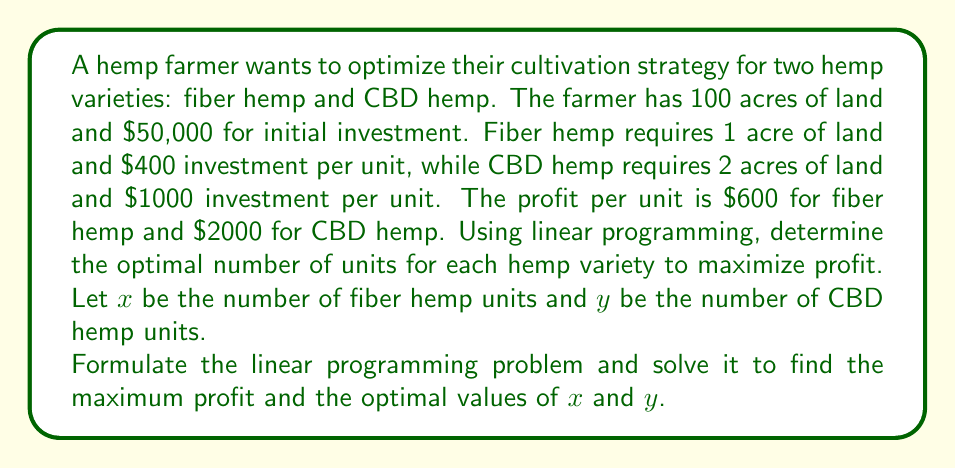Give your solution to this math problem. To solve this linear programming problem, we'll follow these steps:

1. Formulate the objective function and constraints:

   Objective function (maximize profit): 
   $$Z = 600x + 2000y$$

   Constraints:
   Land constraint: $x + 2y \leq 100$ (acres)
   Investment constraint: $400x + 1000y \leq 50000$ (dollars)
   Non-negativity: $x \geq 0, y \geq 0$

2. Graph the constraints:

   [asy]
   size(200,200);
   import graph;

   xaxis("x", 0, 120, Arrow);
   yaxis("y", 0, 60, Arrow);

   draw((0,50)--(100,0), blue);
   draw((0,50)--(125,0), red);
   draw((100,0)--(100,50), green);

   label("Land constraint", (50,25), E, blue);
   label("Investment constraint", (62.5,25), E, red);
   label("x = 100", (100,25), W, green);

   fill((0,0)--(0,50)--(50,25)--(100,0)--cycle, gray(0.8));
   [/asy]

3. Identify the feasible region (shaded area in the graph).

4. Find the corner points of the feasible region:
   (0,0), (0,50), (50,25), (100,0)

5. Evaluate the objective function at each corner point:
   (0,0): Z = 0
   (0,50): Z = 100,000
   (50,25): Z = 80,000
   (100,0): Z = 60,000

6. The maximum value occurs at (0,50), which means:
   x = 0 (fiber hemp units)
   y = 50 (CBD hemp units)

7. Calculate the maximum profit:
   $$Z_{max} = 600(0) + 2000(50) = 100,000$$

Therefore, the optimal solution is to produce 0 units of fiber hemp and 50 units of CBD hemp, resulting in a maximum profit of $100,000.
Answer: $x = 0, y = 50, Z_{max} = $100,000 